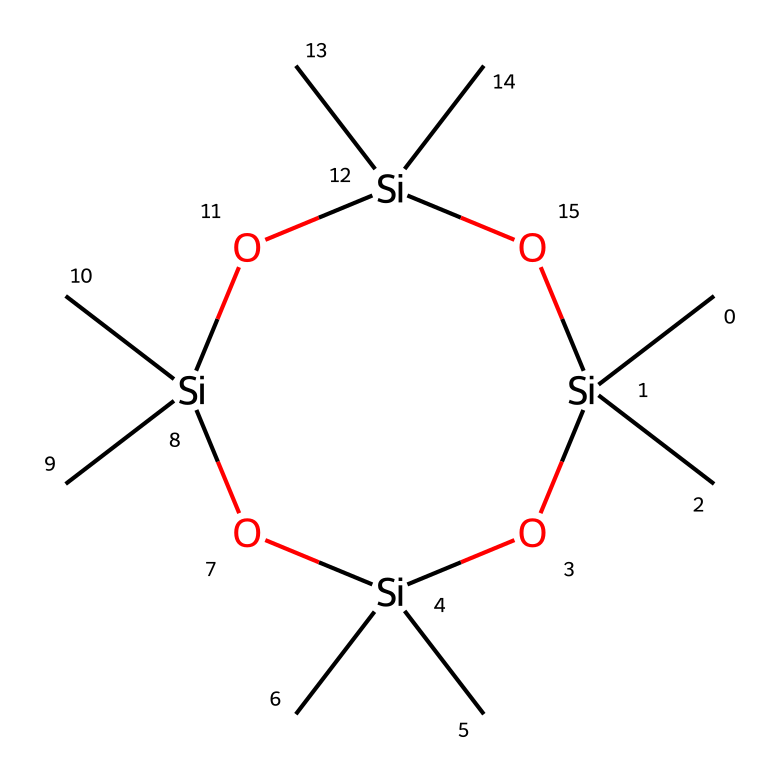What is the molecular formula of octamethylcyclotetrasiloxane? By examining the SMILES representation, we can deduce the molecular formula. Each carbon ('C') represents a carbon atom, the 'Si' represents silicon atoms, and the 'O' represents oxygen atoms. The structure contains 8 carbon atoms, 4 silicon atoms, and 4 oxygen atoms. This yields the formula C8H24O4Si4.
Answer: C8H24O4Si4 How many silicon atoms are present in the structure? The SMILES representation contains four occurrences of 'Si', indicating the presence of four silicon atoms in the structure.
Answer: 4 What type of bonding is primarily present in octamethylcyclotetrasiloxane? The presence of the silicon (Si) atoms linked with oxygen (O) suggests that the bonding is primarily siloxane (Si-O) bonds, which are characteristic of siloxanes.
Answer: siloxane What is the cyclic nature of the structure? The notation with '1' in the SMILES indicates that this structure is a ring; specifically, it is a cyclic compound involving four silicon atoms bridged by oxygen, creating a stable ring structure.
Answer: cyclic How many methyl groups are present in octamethylcyclotetrasiloxane? Each carbon in the structure corresponds to a methyl group. Since there are 8 carbon atoms depicted, there are 8 methyl groups (-CH3) in the compound.
Answer: 8 What functional groups are characteristic of this compound? The combination of silicon and oxygen atoms, particularly in the form of siloxane, indicates that the characteristic functional groups of this compound are siloxane groups.
Answer: siloxane groups 